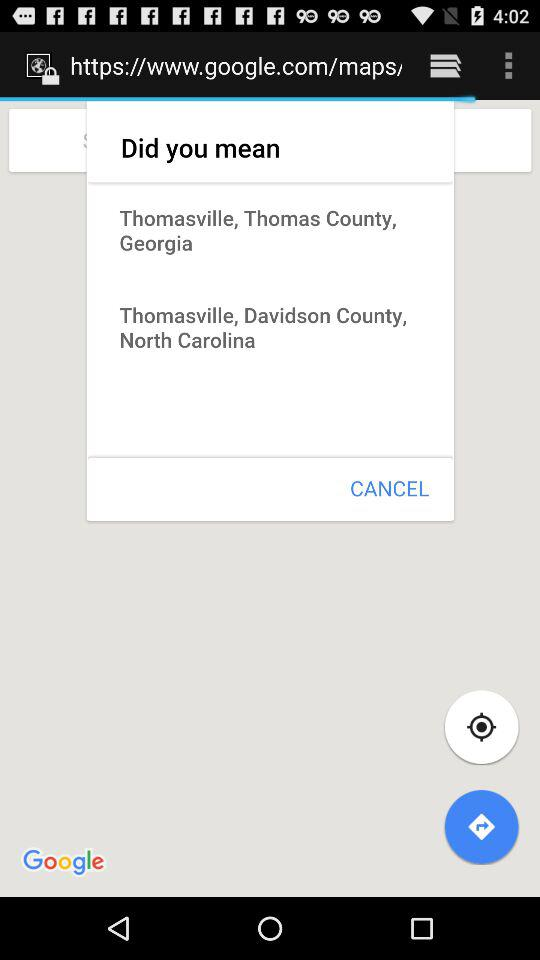What is the country name? The country name is Georgia. 